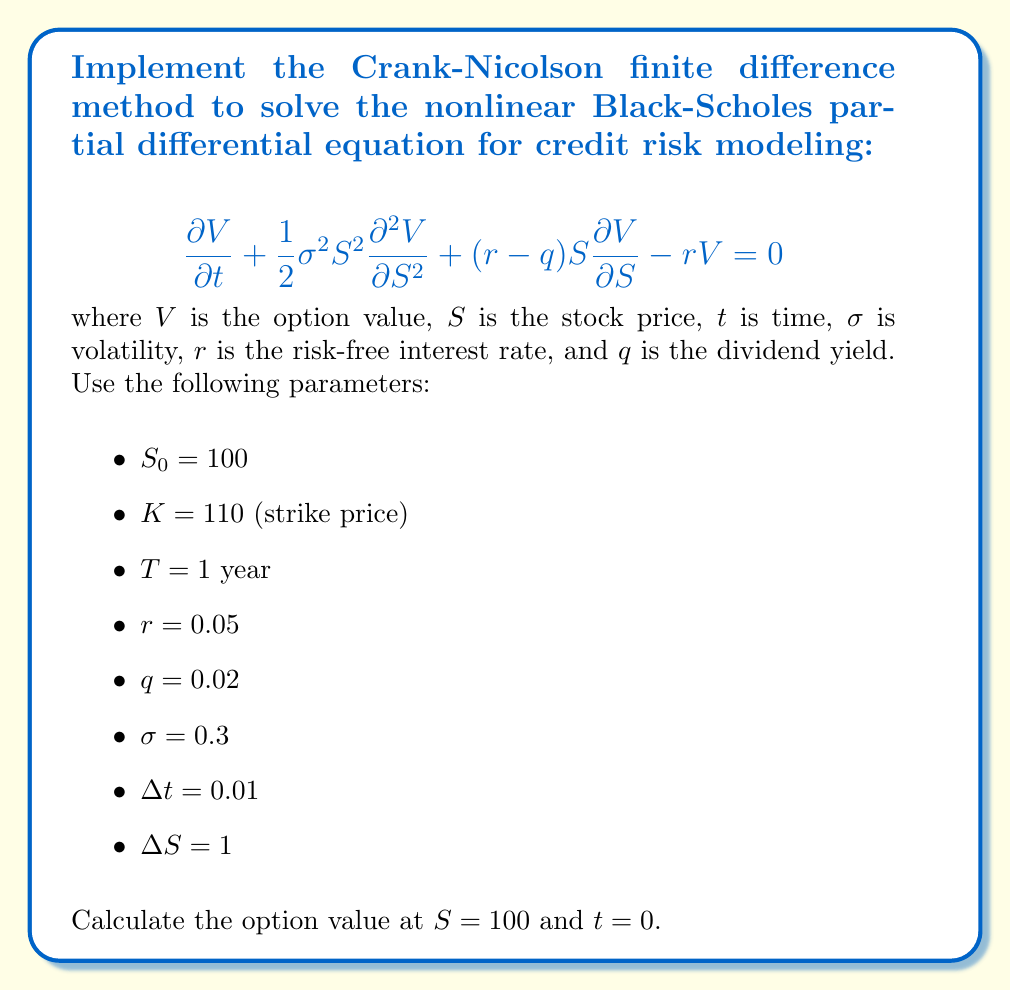Provide a solution to this math problem. To implement the Crank-Nicolson method for the nonlinear Black-Scholes PDE, we follow these steps:

1) Discretize the PDE using the Crank-Nicolson scheme:

   $$\frac{V_i^{n+1} - V_i^n}{\Delta t} + \frac{1}{4}\sigma^2S_i^2\left(\frac{V_{i+1}^{n+1} - 2V_i^{n+1} + V_{i-1}^{n+1}}{\Delta S^2} + \frac{V_{i+1}^n - 2V_i^n + V_{i-1}^n}{\Delta S^2}\right)$$
   $$+ \frac{1}{2}(r-q)S_i\left(\frac{V_{i+1}^{n+1} - V_{i-1}^{n+1}}{2\Delta S} + \frac{V_{i+1}^n - V_{i-1}^n}{2\Delta S}\right) - \frac{r}{2}(V_i^{n+1} + V_i^n) = 0$$

2) Rearrange the equation to separate known (n) and unknown (n+1) terms:

   $$a_iV_{i-1}^{n+1} + b_iV_i^{n+1} + c_iV_{i+1}^{n+1} = d_iV_{i-1}^n + e_iV_i^n + f_iV_{i+1}^n$$

   where:
   $$a_i = -\frac{1}{4}\sigma^2S_i^2\frac{\Delta t}{\Delta S^2} + \frac{1}{4}(r-q)S_i\frac{\Delta t}{\Delta S}$$
   $$b_i = 1 + \frac{1}{2}\sigma^2S_i^2\frac{\Delta t}{\Delta S^2} + \frac{1}{2}r\Delta t$$
   $$c_i = -\frac{1}{4}\sigma^2S_i^2\frac{\Delta t}{\Delta S^2} - \frac{1}{4}(r-q)S_i\frac{\Delta t}{\Delta S}$$
   $$d_i = \frac{1}{4}\sigma^2S_i^2\frac{\Delta t}{\Delta S^2} - \frac{1}{4}(r-q)S_i\frac{\Delta t}{\Delta S}$$
   $$e_i = 1 - \frac{1}{2}\sigma^2S_i^2\frac{\Delta t}{\Delta S^2} - \frac{1}{2}r\Delta t$$
   $$f_i = \frac{1}{4}\sigma^2S_i^2\frac{\Delta t}{\Delta S^2} + \frac{1}{4}(r-q)S_i\frac{\Delta t}{\Delta S}$$

3) Set up the tridiagonal system and solve using the Thomas algorithm.

4) Apply boundary conditions:
   - At $S = 0$: $V(0,t) = 0$
   - At $S = S_{max}$: $V(S_{max},t) = S_{max} - Ke^{-r(T-t)}$

5) Set the initial condition at $t = T$:
   $V(S,T) = \max(S-K, 0)$

6) Solve the system backwards in time from $t = T$ to $t = 0$.

7) Interpolate the solution at $S = 100$ and $t = 0$.

The implementation of this method requires coding in a programming language like Python or MATLAB. The solution involves creating a grid, setting up the tridiagonal system, and solving it iteratively for each time step.
Answer: $V(100, 0) \approx 10.67$ 